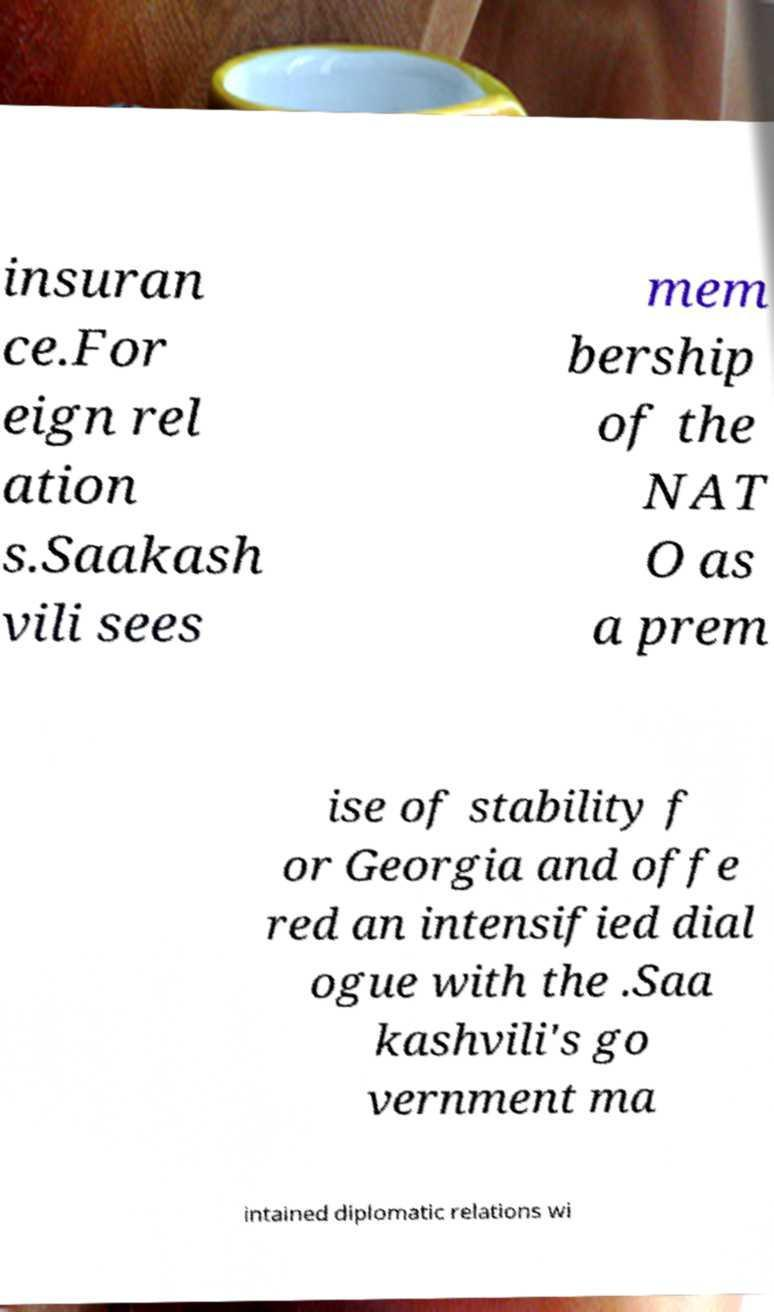Could you assist in decoding the text presented in this image and type it out clearly? insuran ce.For eign rel ation s.Saakash vili sees mem bership of the NAT O as a prem ise of stability f or Georgia and offe red an intensified dial ogue with the .Saa kashvili's go vernment ma intained diplomatic relations wi 